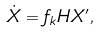Convert formula to latex. <formula><loc_0><loc_0><loc_500><loc_500>\dot { X } = f _ { k } H X ^ { \prime } ,</formula> 